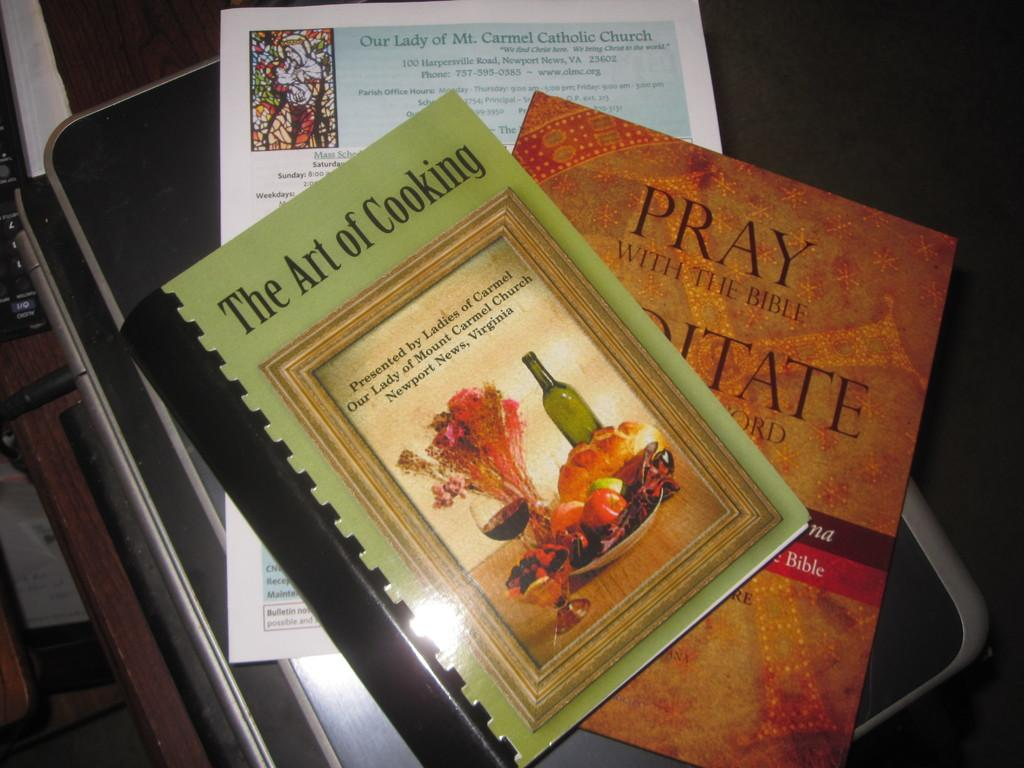<image>
Give a short and clear explanation of the subsequent image. Two books are on a table and one is called "The Art of Cooking." 